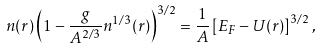Convert formula to latex. <formula><loc_0><loc_0><loc_500><loc_500>n ( { r } ) \left ( 1 - \frac { g } { A ^ { 2 / 3 } } n ^ { 1 / 3 } ( { r } ) \right ) ^ { 3 / 2 } = \frac { 1 } { A } \left [ E _ { F } - U ( { r } ) \right ] ^ { 3 / 2 } ,</formula> 